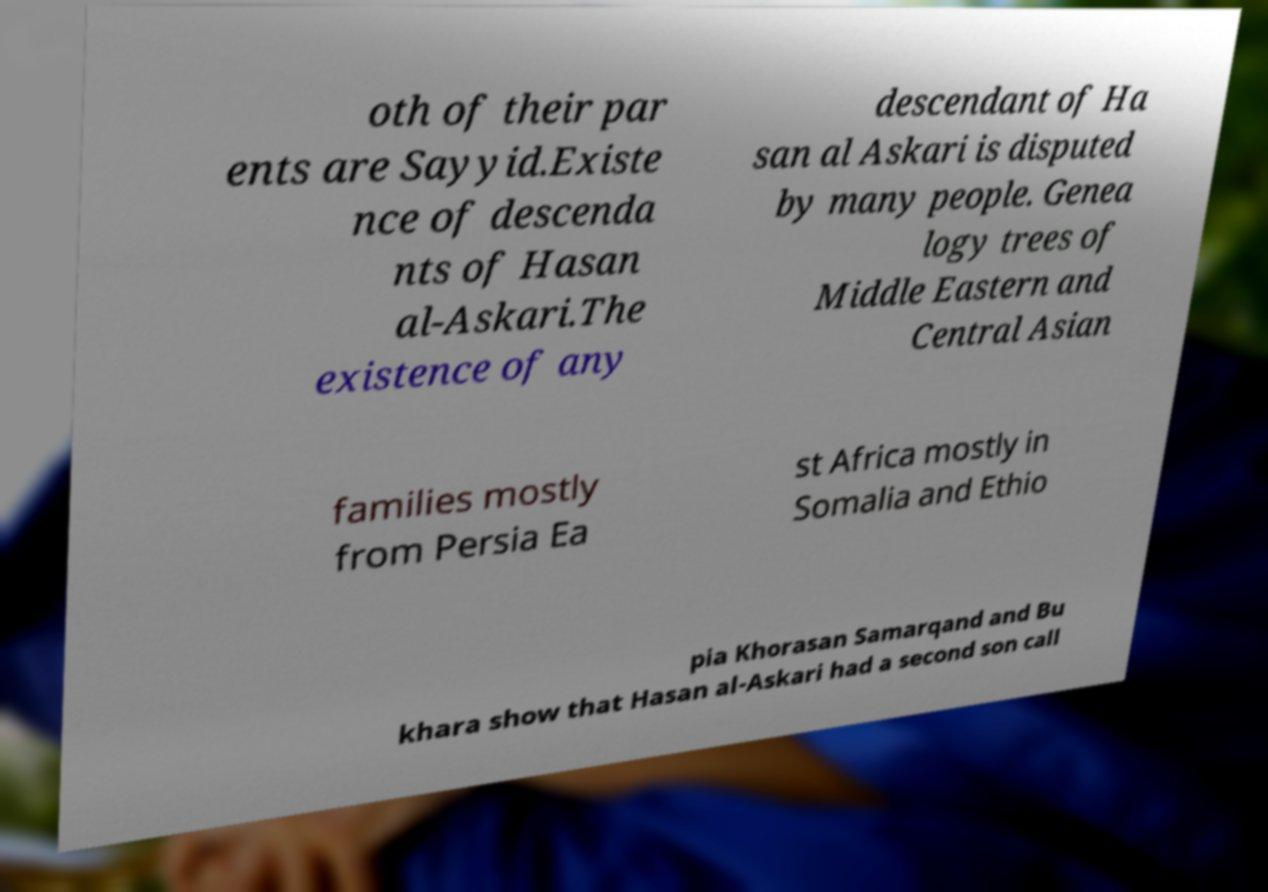Can you read and provide the text displayed in the image?This photo seems to have some interesting text. Can you extract and type it out for me? oth of their par ents are Sayyid.Existe nce of descenda nts of Hasan al-Askari.The existence of any descendant of Ha san al Askari is disputed by many people. Genea logy trees of Middle Eastern and Central Asian families mostly from Persia Ea st Africa mostly in Somalia and Ethio pia Khorasan Samarqand and Bu khara show that Hasan al-Askari had a second son call 